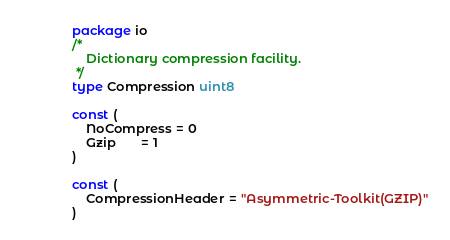<code> <loc_0><loc_0><loc_500><loc_500><_Go_>package io
/*
	Dictionary compression facility.
 */
type Compression uint8

const (
	NoCompress = 0
	Gzip       = 1
)

const (
	CompressionHeader = "Asymmetric-Toolkit(GZIP)"
)
</code> 